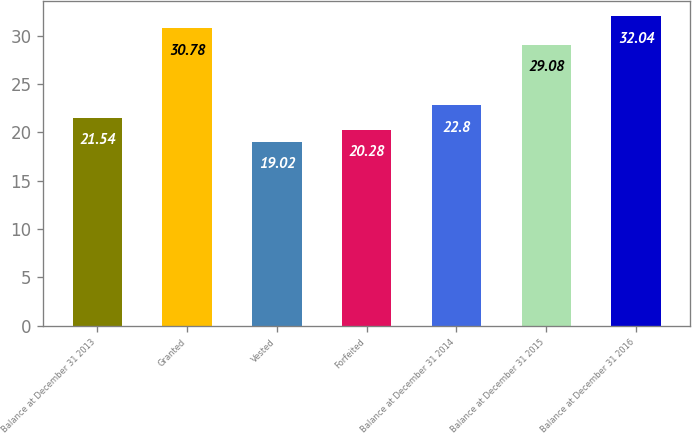Convert chart. <chart><loc_0><loc_0><loc_500><loc_500><bar_chart><fcel>Balance at December 31 2013<fcel>Granted<fcel>Vested<fcel>Forfeited<fcel>Balance at December 31 2014<fcel>Balance at December 31 2015<fcel>Balance at December 31 2016<nl><fcel>21.54<fcel>30.78<fcel>19.02<fcel>20.28<fcel>22.8<fcel>29.08<fcel>32.04<nl></chart> 